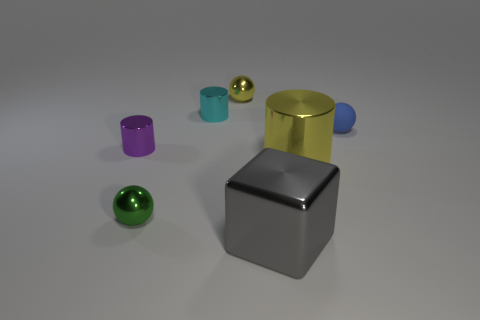Add 2 metallic cubes. How many objects exist? 9 Subtract all blocks. How many objects are left? 6 Add 3 small blue metallic objects. How many small blue metallic objects exist? 3 Subtract 0 purple cubes. How many objects are left? 7 Subtract all cyan things. Subtract all cyan objects. How many objects are left? 5 Add 1 purple metallic cylinders. How many purple metallic cylinders are left? 2 